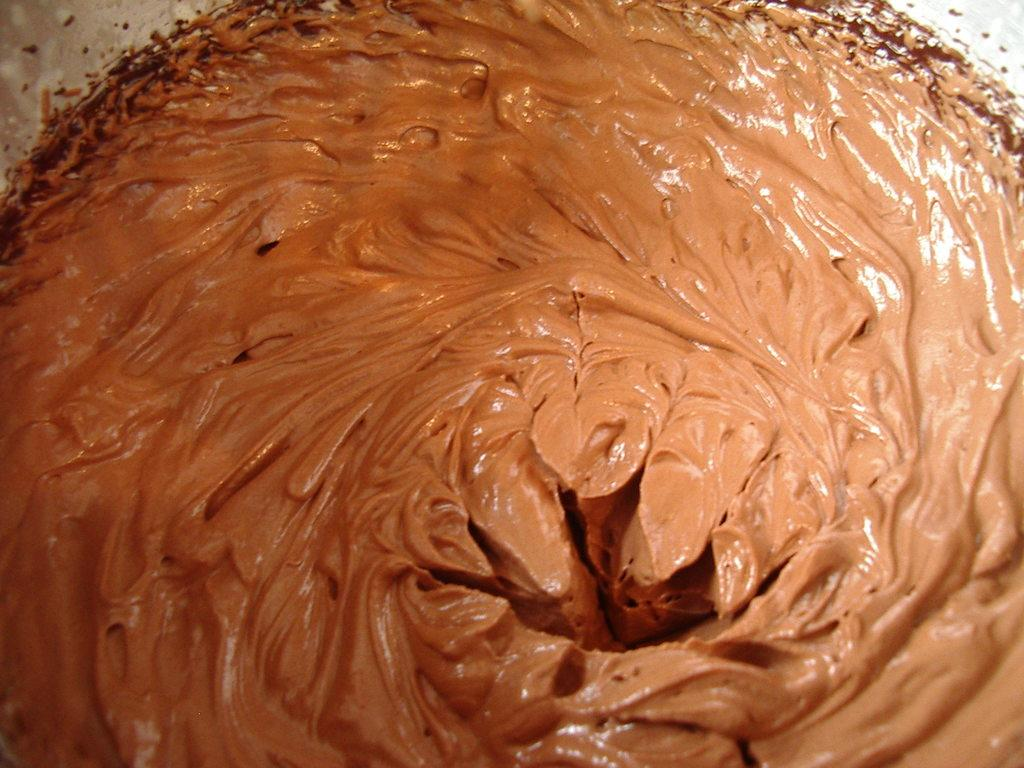Can you describe the overall scene in the image? The image appears to depict a colorful and lively atmosphere, possibly featuring a gathering or event. Reasoning: Since there are no specific facts to work with, we can only provide a general description of the image based on the provided text. We avoid making assumptions about the image and focus on the overall mood or atmosphere. Absurd Question/Answer: What type of cart is being used to transport the agreement in the image? There is no cart or agreement present in the image, as the description is subjective and not a factual observation. 